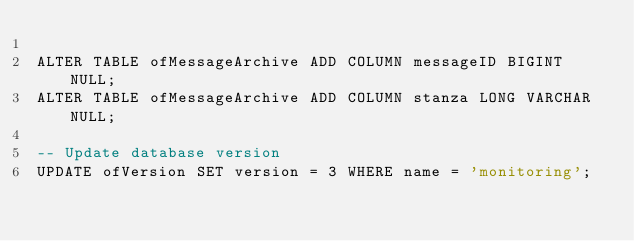Convert code to text. <code><loc_0><loc_0><loc_500><loc_500><_SQL_>
ALTER TABLE ofMessageArchive ADD COLUMN messageID BIGINT NULL;
ALTER TABLE ofMessageArchive ADD COLUMN stanza LONG VARCHAR NULL;

-- Update database version
UPDATE ofVersion SET version = 3 WHERE name = 'monitoring';
</code> 